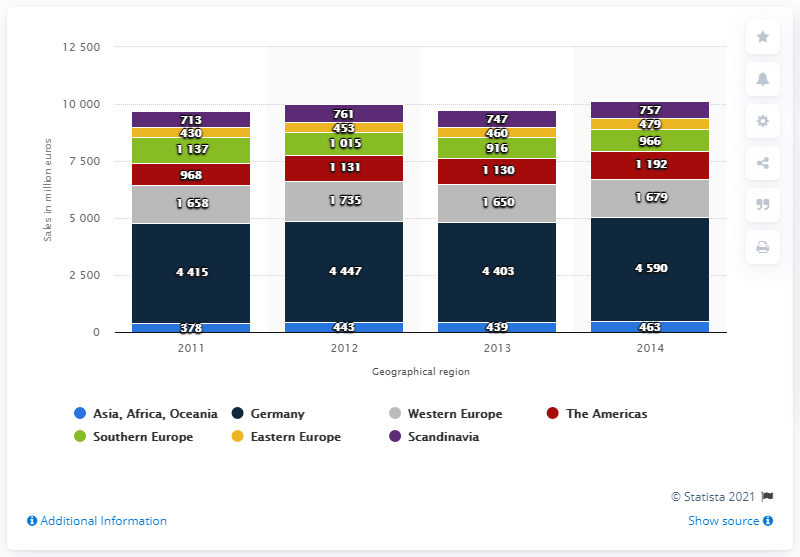Specify some key components in this picture. In 2011, the bar with the lowest value was of a blue color. In 2012 and 2013, the ratio of Western Europe sales was 1.051515152, indicating a slight increase in sales between the two years. The German region of the Würth Group generated a total of 4,403 sales in 2012. 